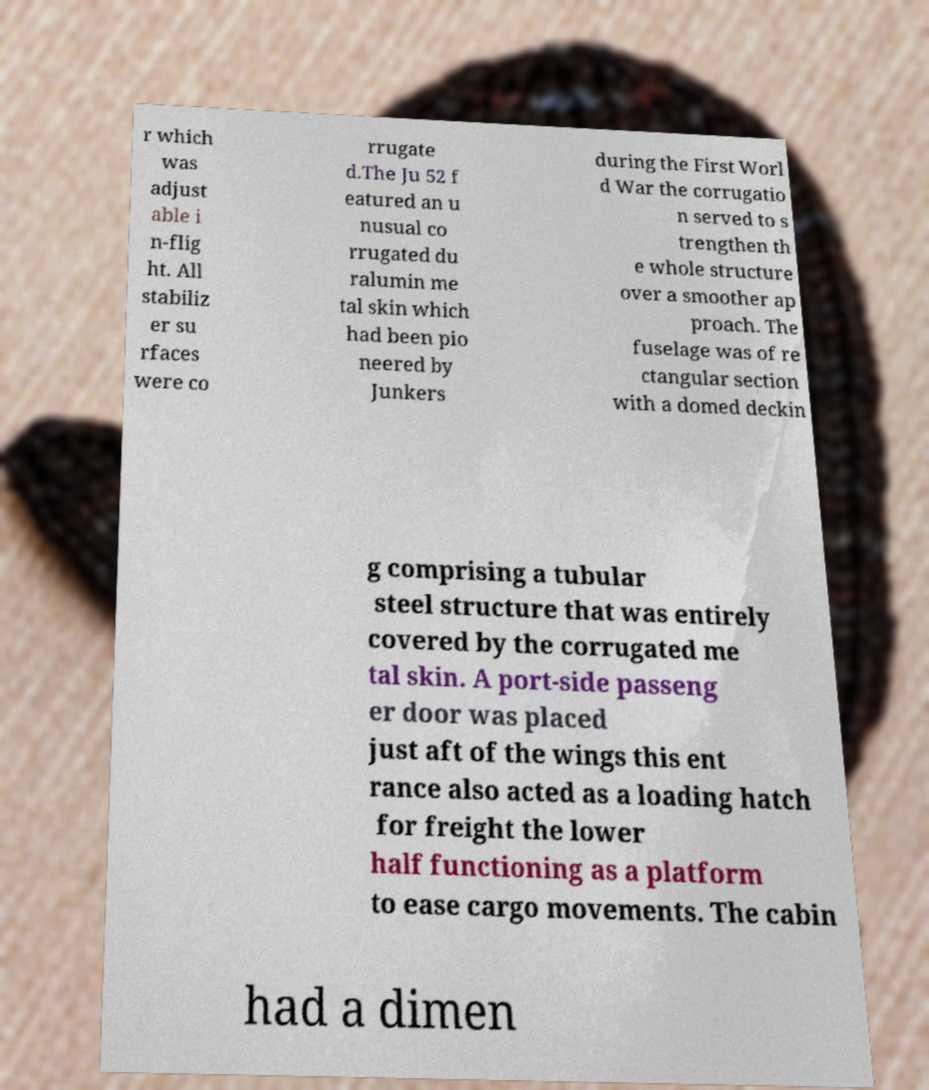I need the written content from this picture converted into text. Can you do that? r which was adjust able i n-flig ht. All stabiliz er su rfaces were co rrugate d.The Ju 52 f eatured an u nusual co rrugated du ralumin me tal skin which had been pio neered by Junkers during the First Worl d War the corrugatio n served to s trengthen th e whole structure over a smoother ap proach. The fuselage was of re ctangular section with a domed deckin g comprising a tubular steel structure that was entirely covered by the corrugated me tal skin. A port-side passeng er door was placed just aft of the wings this ent rance also acted as a loading hatch for freight the lower half functioning as a platform to ease cargo movements. The cabin had a dimen 